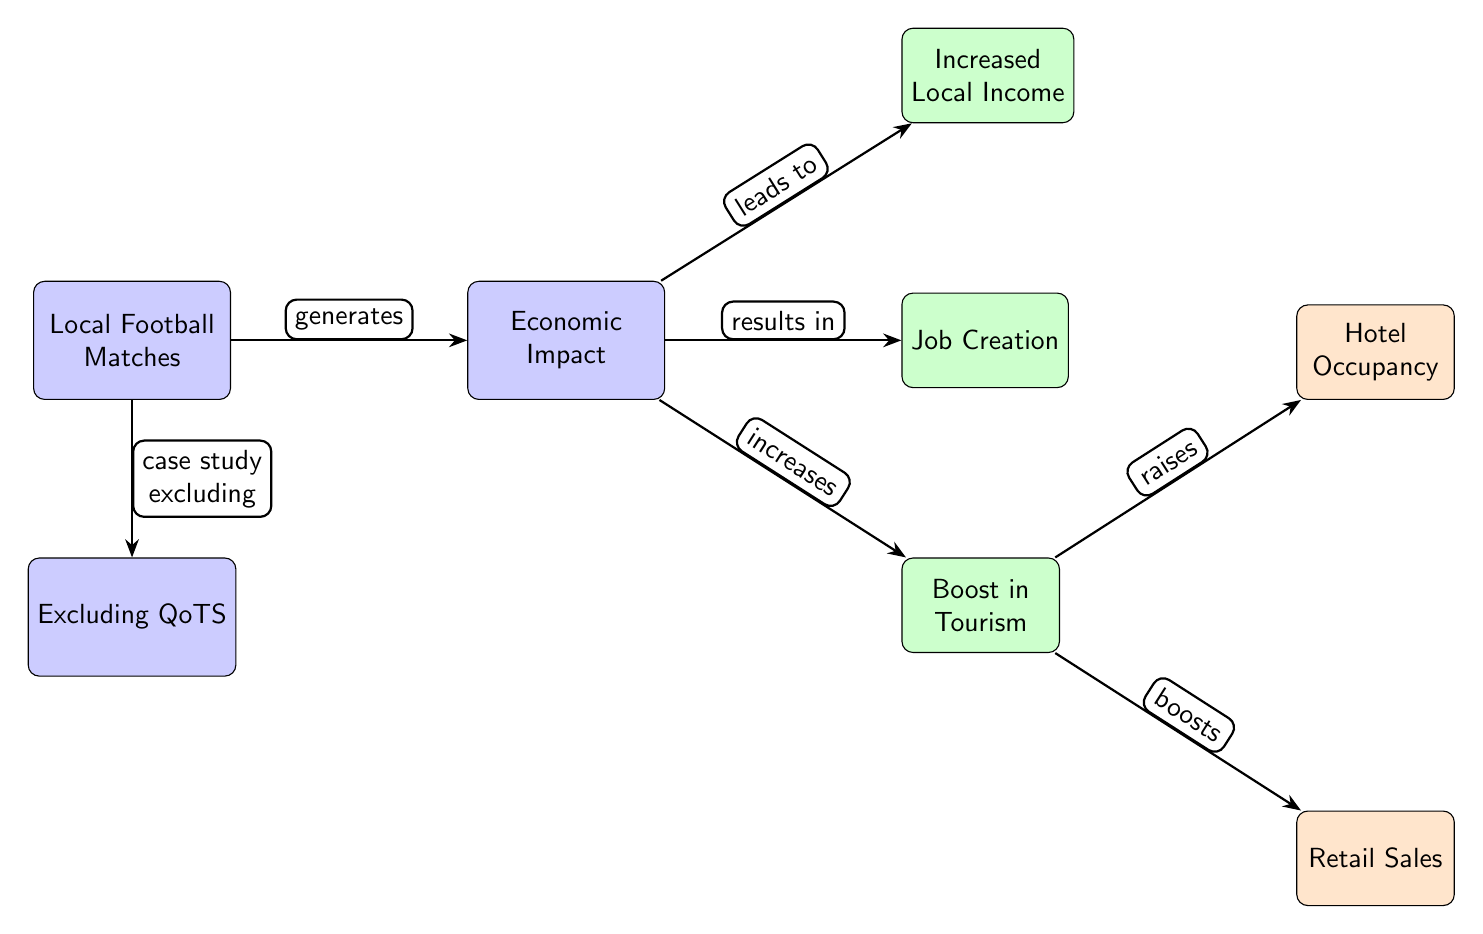What generates the economic impact? The diagram indicates that local football matches are the primary element that generates the economic impact. This is understood by tracing the edge labeled "generates" that connects the 'Local Football Matches' node to the 'Economic Impact' node.
Answer: Local Football Matches How many secondary nodes are present? By counting the secondary nodes that directly connect to the 'Economic Impact' node (Increased Local Income, Job Creation, Boost in Tourism), we find there are three secondary nodes in total.
Answer: 3 What is the relationship between tourism and retail sales? The 'Boost in Tourism' node leads to both 'Hotel Occupancy' and 'Retail Sales', which indicates that tourism influences retail sales positively as indicated by the edge marked "boosts." This connection suggests an economic relationship between increased tourism and retail.
Answer: boosts Which node is at the bottom of the diagram? The node labeled 'Excluding QoTS' is located directly below the 'Local Football Matches' node, and this gives us the structure showing that it pertains to the exclusion of Queen of the South from the study.
Answer: Excluding QoTS What does the 'Economic Impact' lead to in terms of increased local opportunities? The 'Economic Impact' leads to 'Increased Local Income', 'Job Creation', and 'Boost in Tourism', indicating that a positive economic impact results in various local economic benefits. This shows a network of local opportunities stemming from the economic impact arising from football matches (excluding QoTS).
Answer: Increased Local Income, Job Creation, Boost in Tourism 